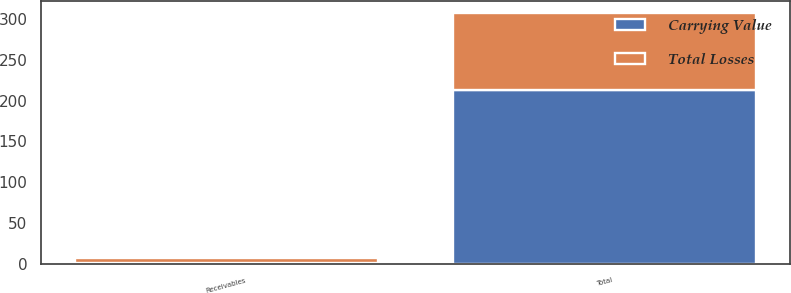Convert chart. <chart><loc_0><loc_0><loc_500><loc_500><stacked_bar_chart><ecel><fcel>Receivables<fcel>Total<nl><fcel>Carrying Value<fcel>1<fcel>213<nl><fcel>Total Losses<fcel>6<fcel>94<nl></chart> 